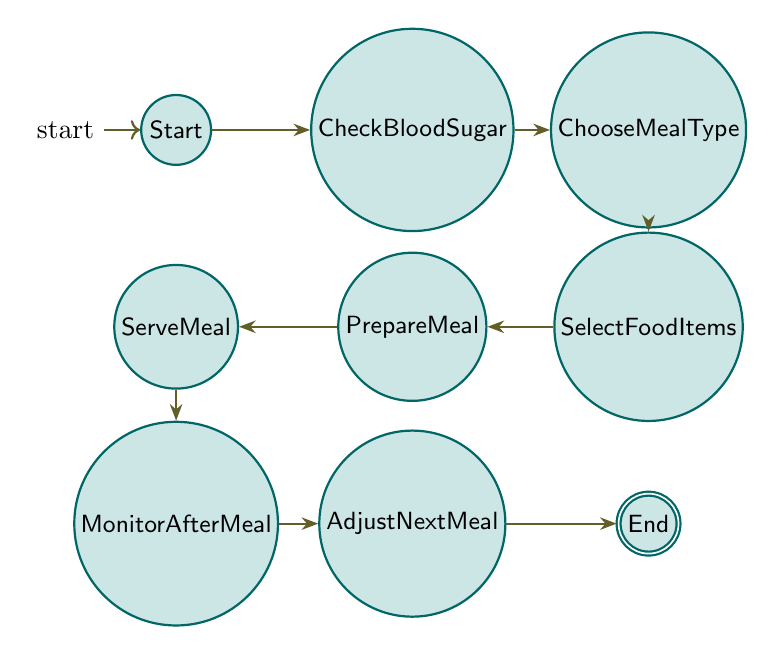What is the initial state of the meal planning process? The diagram starts with the state labeled "Start," which denotes the beginning of the meal planning for a diabetic child.
Answer: Start How many states are there in the diagram? By counting the states listed, there are a total of eight distinct states presented in the diagram.
Answer: 8 What is the last state in the meal planning process? The final state of the diagram, which represents the end of the meal planning process, is labeled "End."
Answer: End Which state follows "Serve Meal"? The state that directly follows "Serve Meal" in the sequence of the diagram is "Monitor After Meal," indicating the step taken after the meal is served.
Answer: Monitor After Meal What is the relationship between "Choose Meal Type" and "Select Food Items"? In the diagram, "Choose Meal Type" transitions directly to "Select Food Items," which shows a direct connection as part of the meal planning process.
Answer: Select Food Items What should be done after measuring the child's blood sugar level? After obtaining the blood sugar level, the next action in the sequence is to "Choose Meal Type," which indicates the focus on meal selection following this measurement.
Answer: Choose Meal Type What must be adjusted based on the monitored blood sugar levels? After monitoring blood sugar levels post-meal, the next step requires making adjustments to the upcoming meal plan, which is represented in the diagram as "Adjust Next Meal."
Answer: Adjust Next Meal What flows from "Monitor After Meal"? The state that is reached next after "Monitor After Meal" is "Adjust Next Meal," indicating adaptation depending on the monitored outcomes.
Answer: Adjust Next Meal 